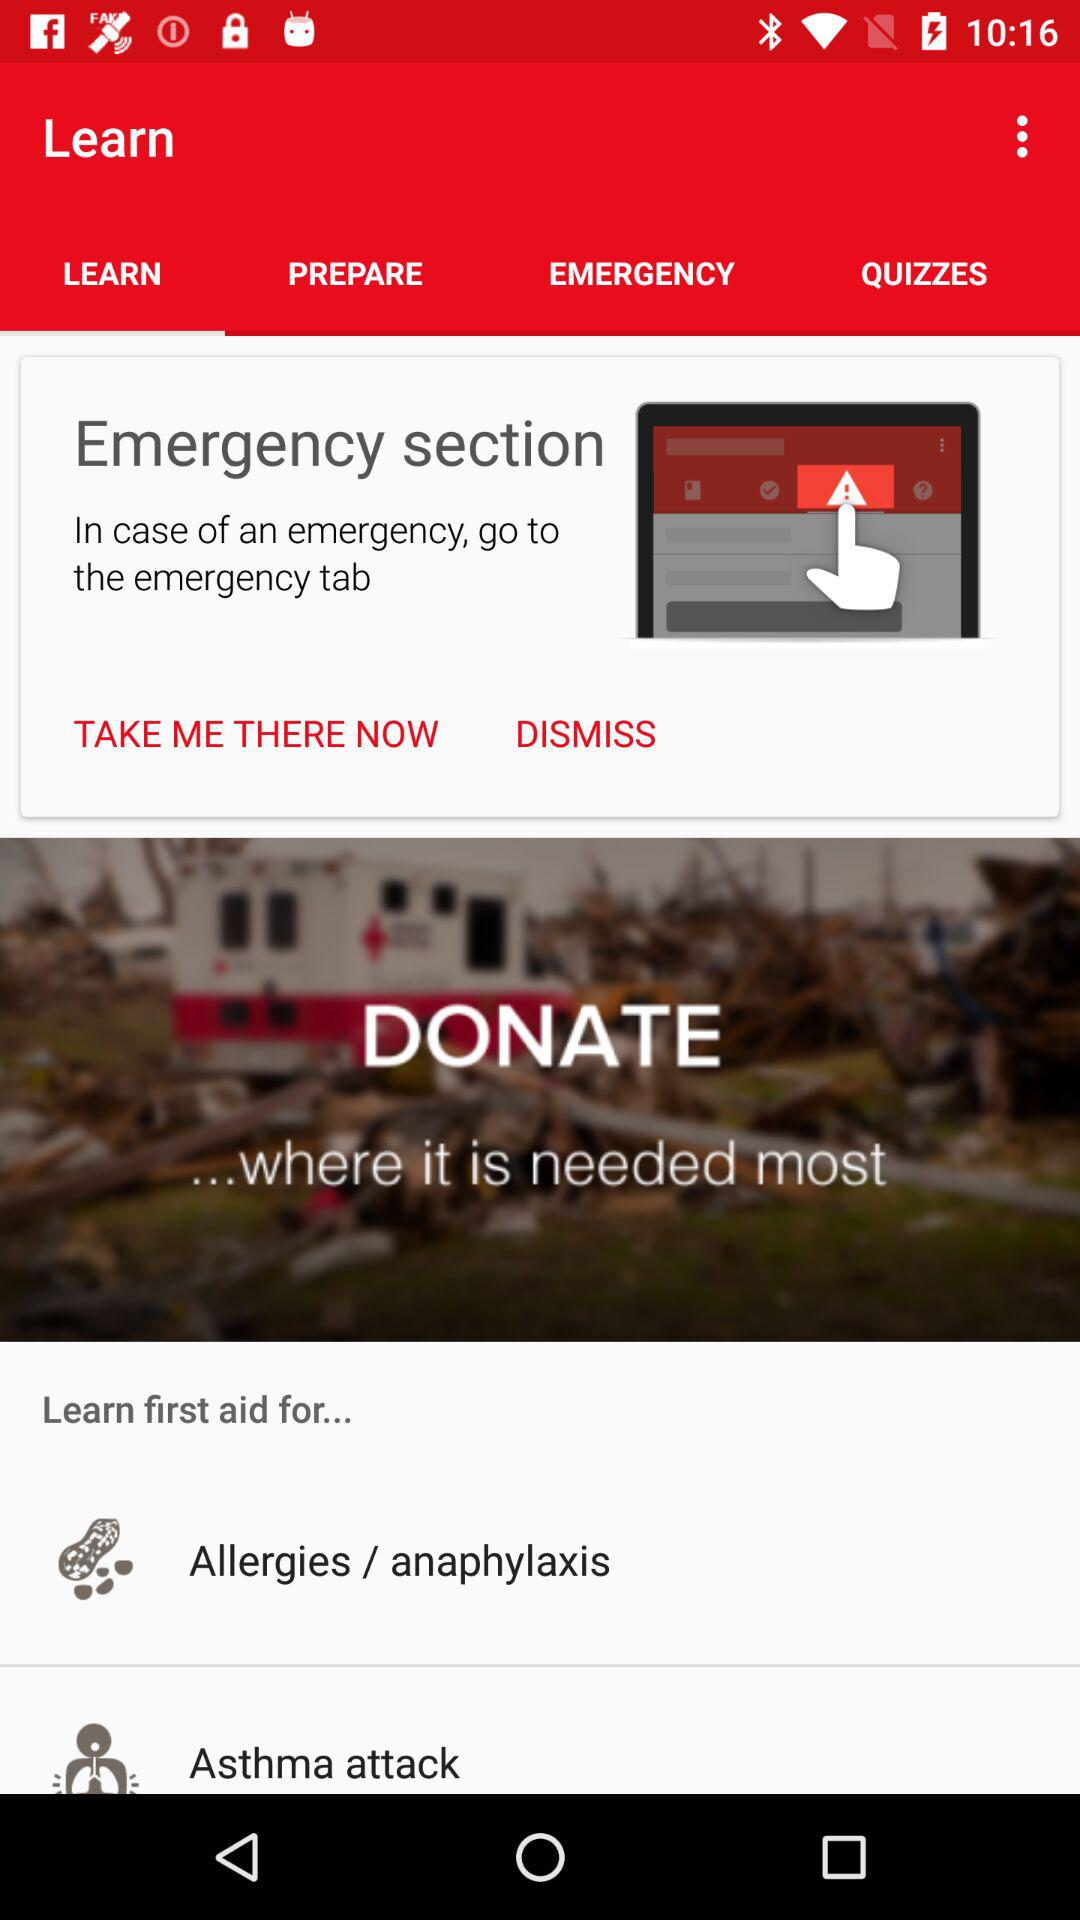Which tab is selected? The selected tab is "LEARN". 